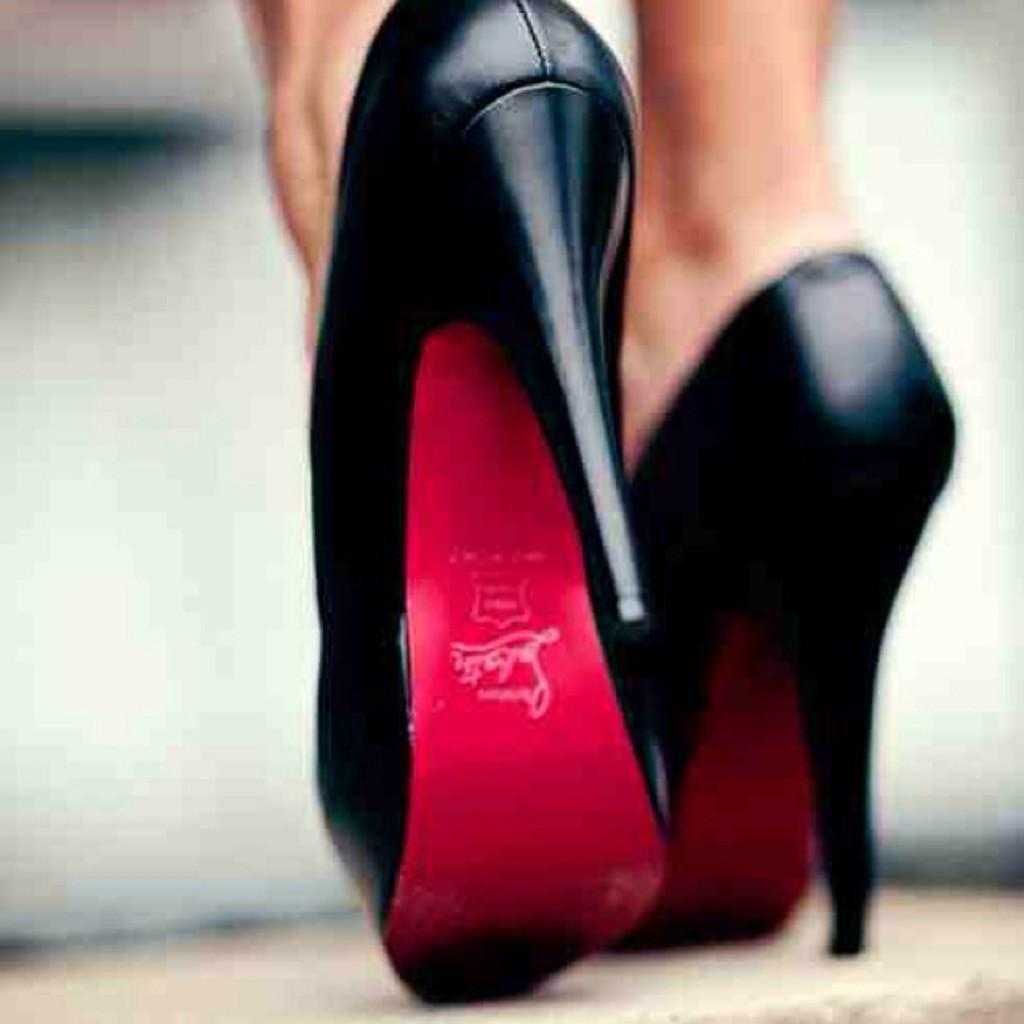How would you summarize this image in a sentence or two? In this image we can see the legs of a person, also we can see footwear, and the background is blurred. 